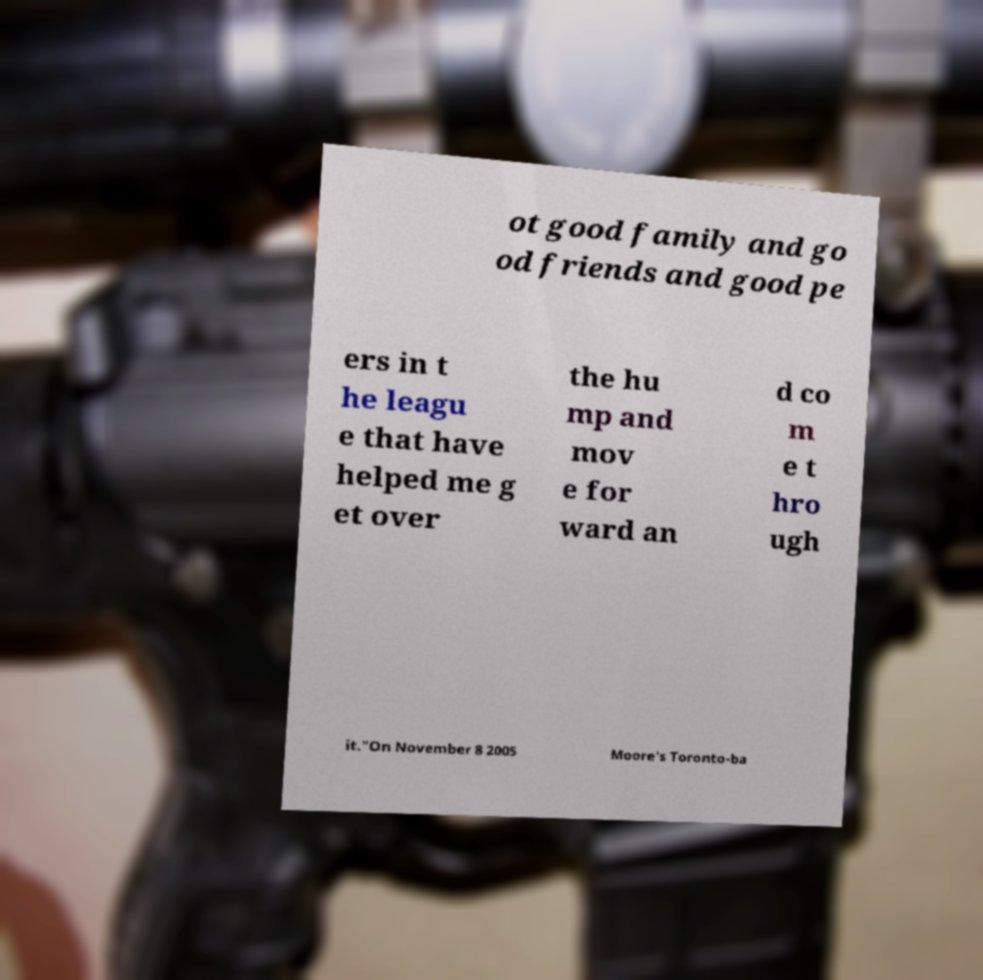Can you read and provide the text displayed in the image?This photo seems to have some interesting text. Can you extract and type it out for me? ot good family and go od friends and good pe ers in t he leagu e that have helped me g et over the hu mp and mov e for ward an d co m e t hro ugh it."On November 8 2005 Moore's Toronto-ba 